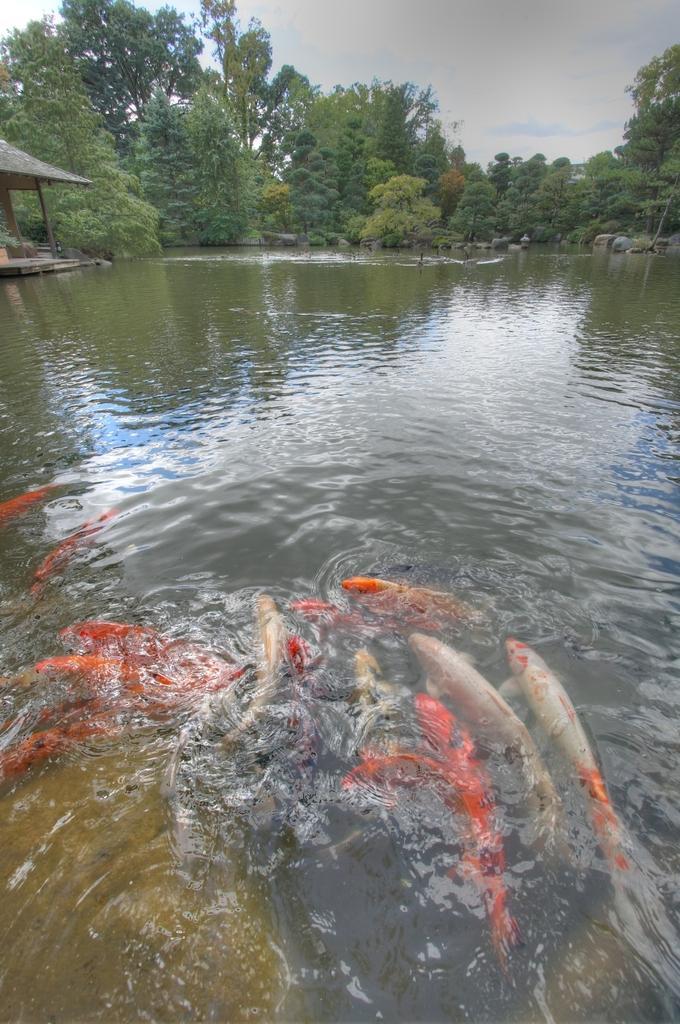Describe this image in one or two sentences. This picture is taken from outside of the city. In this image, in the middle, we can see some fishes which are in the water. On the left side, we can see a hut. In the background, we can see some trees and plants, rocks. At the top, we can see a sky, at the bottom, we can see a water in a lake. 